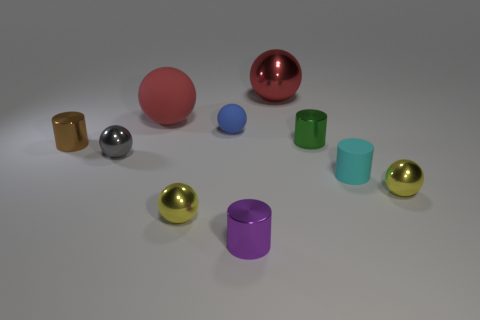Is the big metallic thing the same color as the large matte thing?
Provide a short and direct response. Yes. Are there any other things that are the same color as the big metallic object?
Your response must be concise. Yes. Are the tiny green thing and the tiny cyan thing that is in front of the blue matte sphere made of the same material?
Your answer should be very brief. No. There is a yellow object that is on the right side of the small yellow object left of the large red metallic thing; what shape is it?
Make the answer very short. Sphere. What number of big objects are either green metallic spheres or yellow metal things?
Your answer should be very brief. 0. How many other big metal objects have the same shape as the big red shiny thing?
Your answer should be compact. 0. There is a brown object; is it the same shape as the yellow thing left of the tiny blue rubber sphere?
Your answer should be very brief. No. What number of matte cylinders are in front of the green metal thing?
Your answer should be compact. 1. Is there a brown metallic cylinder of the same size as the green metal cylinder?
Your answer should be compact. Yes. Is the shape of the yellow metallic thing to the right of the small purple object the same as  the blue matte object?
Give a very brief answer. Yes. 